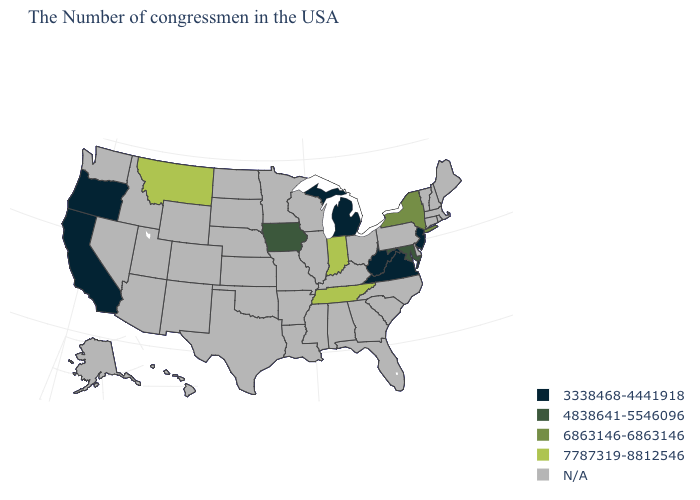What is the value of Pennsylvania?
Give a very brief answer. N/A. What is the value of New Jersey?
Give a very brief answer. 3338468-4441918. What is the highest value in states that border Wyoming?
Concise answer only. 7787319-8812546. What is the highest value in the USA?
Be succinct. 7787319-8812546. Name the states that have a value in the range 7787319-8812546?
Quick response, please. Indiana, Tennessee, Montana. Name the states that have a value in the range 4838641-5546096?
Be succinct. Maryland, Iowa. Does New York have the lowest value in the USA?
Write a very short answer. No. What is the highest value in the Northeast ?
Keep it brief. 6863146-6863146. What is the highest value in the USA?
Give a very brief answer. 7787319-8812546. Is the legend a continuous bar?
Concise answer only. No. Name the states that have a value in the range 7787319-8812546?
Answer briefly. Indiana, Tennessee, Montana. Name the states that have a value in the range 4838641-5546096?
Concise answer only. Maryland, Iowa. Name the states that have a value in the range N/A?
Answer briefly. Maine, Massachusetts, Rhode Island, New Hampshire, Vermont, Connecticut, Delaware, Pennsylvania, North Carolina, South Carolina, Ohio, Florida, Georgia, Kentucky, Alabama, Wisconsin, Illinois, Mississippi, Louisiana, Missouri, Arkansas, Minnesota, Kansas, Nebraska, Oklahoma, Texas, South Dakota, North Dakota, Wyoming, Colorado, New Mexico, Utah, Arizona, Idaho, Nevada, Washington, Alaska, Hawaii. Name the states that have a value in the range 7787319-8812546?
Be succinct. Indiana, Tennessee, Montana. 